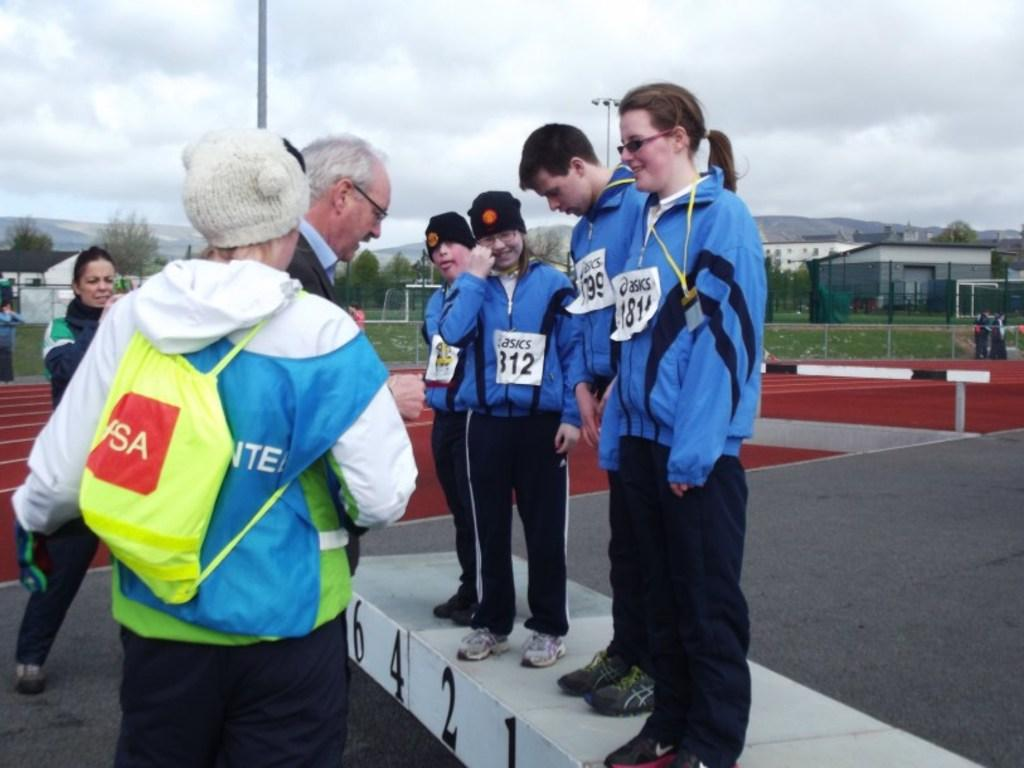<image>
Present a compact description of the photo's key features. People are lined up on a winners' podium with Asics brand number signs on their jackets. 